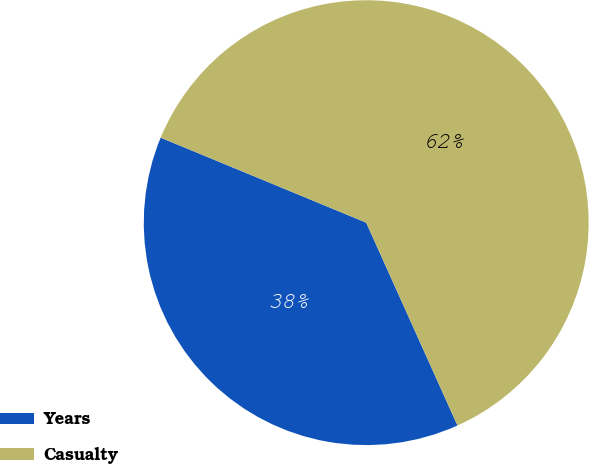Convert chart to OTSL. <chart><loc_0><loc_0><loc_500><loc_500><pie_chart><fcel>Years<fcel>Casualty<nl><fcel>37.97%<fcel>62.03%<nl></chart> 